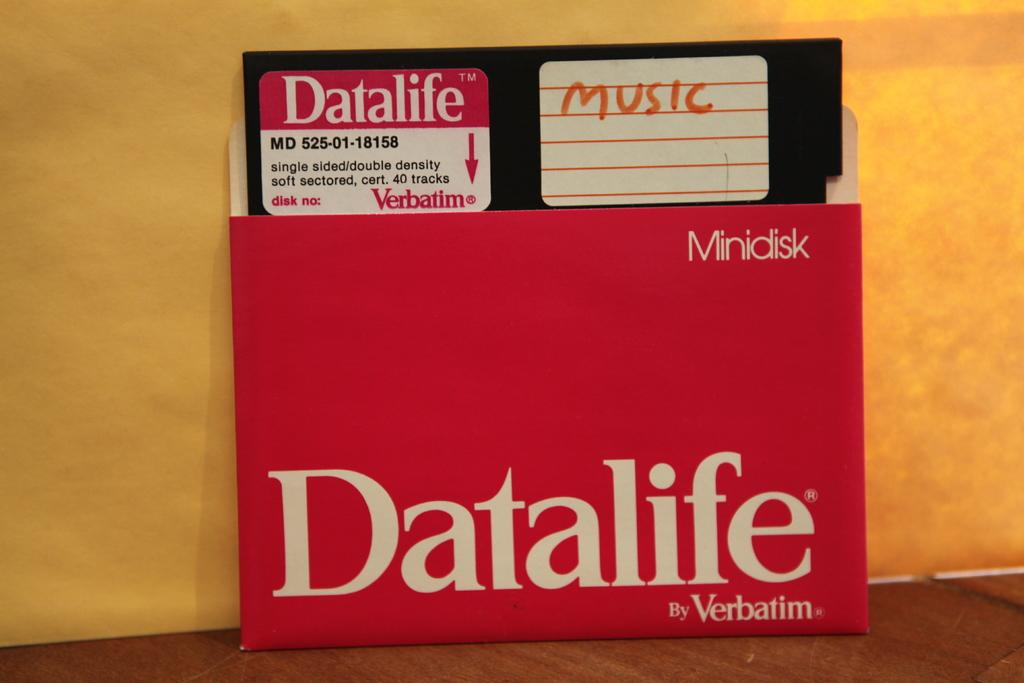<image>
Write a terse but informative summary of the picture. Minidisk Datalife by Verbatium that contains music on a disc. 